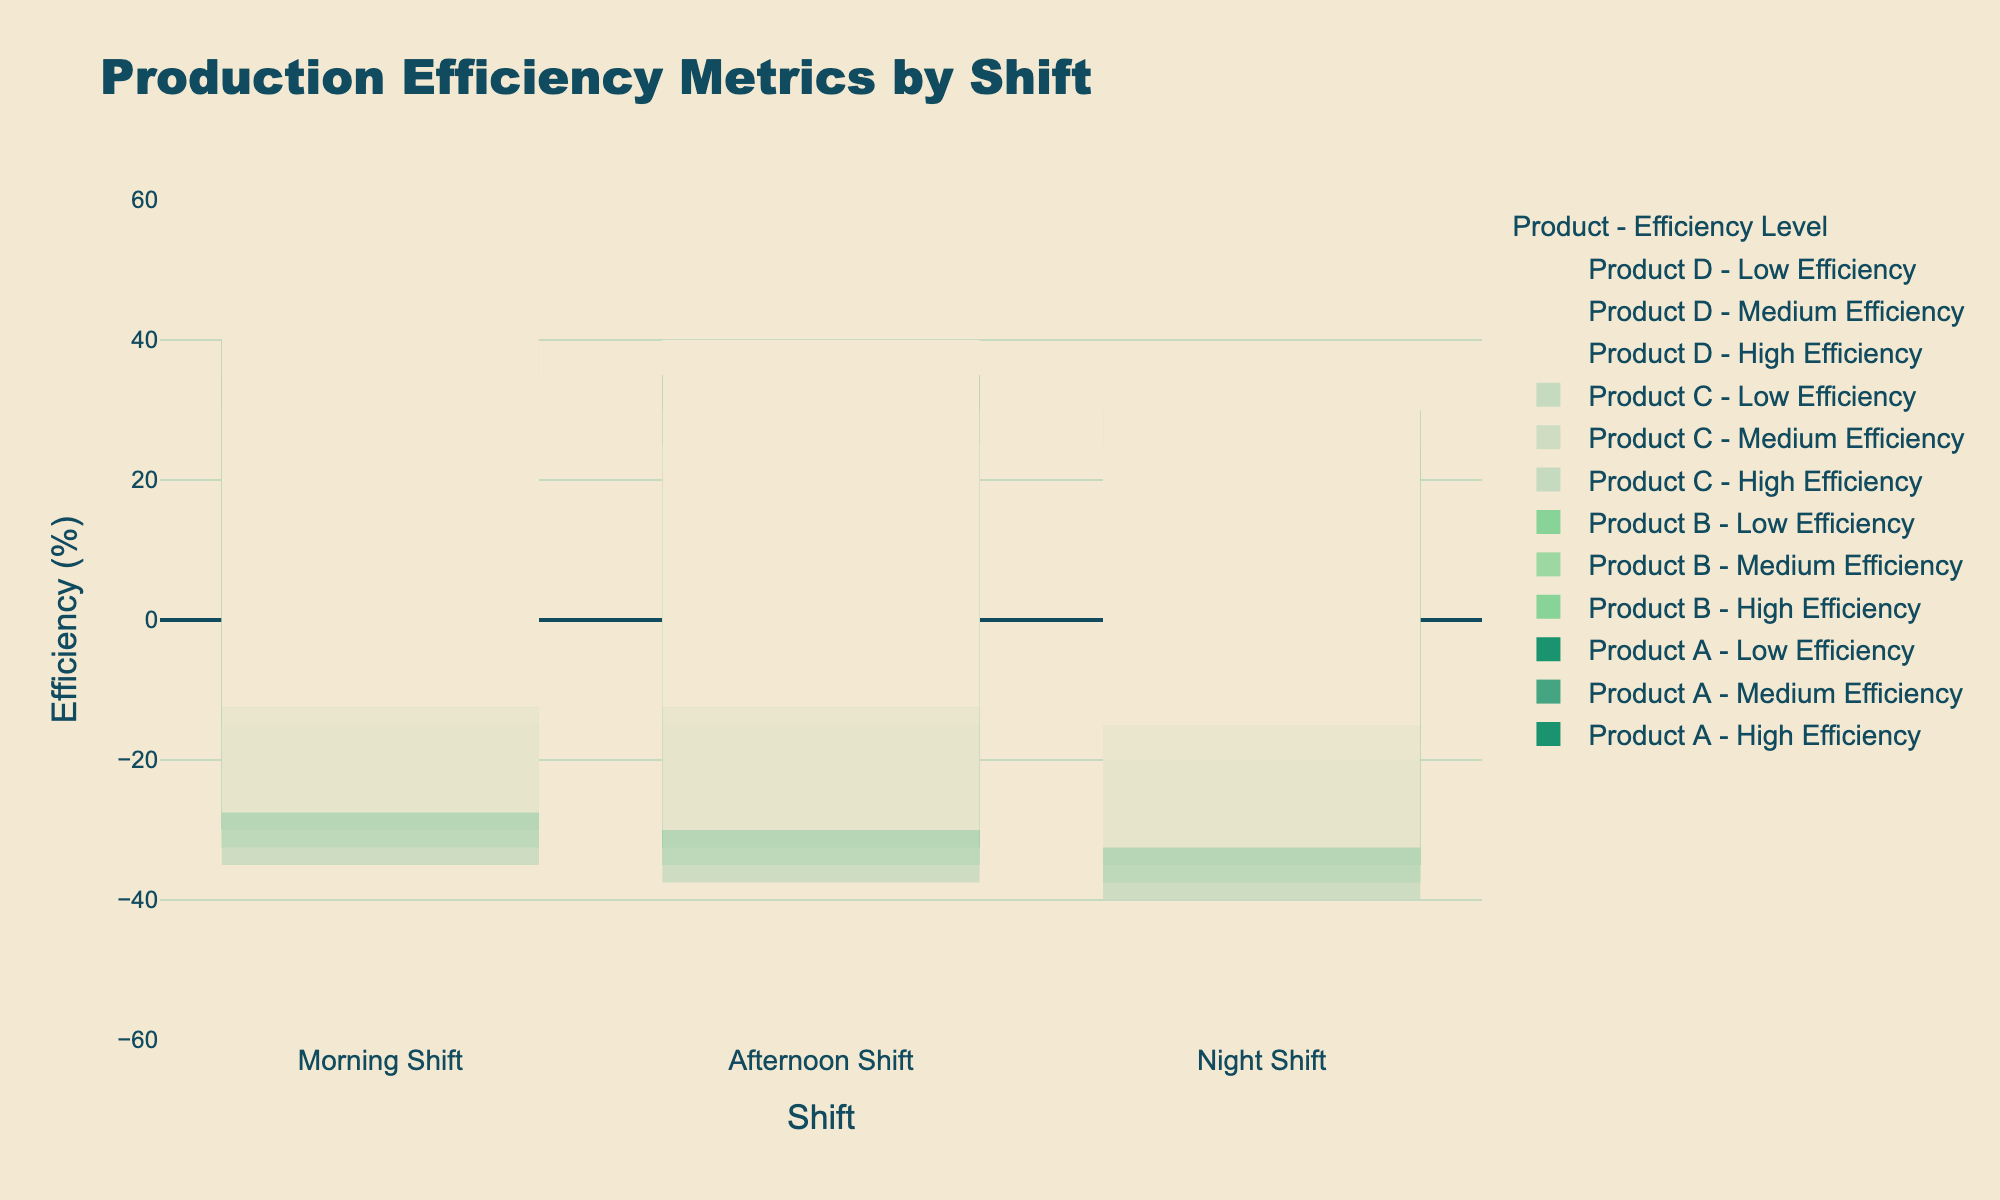What is the difference in the high efficiency percentage for Product A between the Morning Shift and Night Shift? In the Morning Shift, Product A has a high efficiency of 40%. In the Night Shift, Product A has a high efficiency of 30%. The difference is 40% - 30% = 10%.
Answer: 10% Which shift has the highest average high efficiency percentage across all products? Calculate the average high efficiency percentage for each shift. For Morning Shift: (40+35+30+45)/4 = 37.5%. For Afternoon Shift: (35+30+25+40)/4 = 32.5%. For Night Shift: (30+25+20+35)/4 = 27.5%. The Morning Shift has the highest average high efficiency percentage.
Answer: Morning Shift How does the total medium efficiency percentage for Product C compare between the Morning Shift and Afternoon Shift? In the Morning Shift, Product C has a medium efficiency of 40%. In the Afternoon Shift, Product C has a medium efficiency of 45%. The Afternoon Shift has a higher medium efficiency percentage by 45% - 40% = 5%.
Answer: Afternoon Shift has 5% more Which product has the lowest low efficiency percentage in the Night Shift? In the Night Shift, the low efficiency percentages are: Product A: 35%, Product B: 35%, Product C: 40%, Product D: 30%. Product D has the lowest low efficiency percentage at 30%.
Answer: Product D Compare the high efficiency percentage for Product D between the Morning Shift and Afternoon Shift. In the Morning Shift, Product D has a high efficiency of 45%. In the Afternoon Shift, Product D has a high efficiency of 40%. The Morning Shift has a higher high efficiency percentage by 45% - 40% = 5%.
Answer: Morning Shift has 5% more Which product's efficiency remains constant across all shifts for the low efficiency metric? Compare the low efficiency percentages across all shifts: Product A: 30%, 30%, 30%; Product B: 30%, 30%, 35%; Product C: 30%, 30%, 40%; Product D: 25%, 25%, 30%. Product A has constant low efficiency across all shifts.
Answer: Product A What is the sum of high and medium efficiency percentages for Product B in the Afternoon Shift? In the Afternoon Shift, Product B has a high efficiency of 30% and a medium efficiency of 40%. The sum is 30% + 40% = 70%.
Answer: 70% If you combine high and medium efficiency percentages, which product has the highest percentage in the Morning Shift? Combine high and medium efficiency percentages for the Morning Shift: Product A: 40% + 30% = 70%, Product B: 35% + 35% = 70%, Product C: 30% + 40% = 70%, Product D: 45% + 30% = 75%. Product D has the highest combined percentage at 75%.
Answer: Product D 